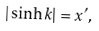Convert formula to latex. <formula><loc_0><loc_0><loc_500><loc_500>| \sinh k | = x ^ { \prime } ,</formula> 